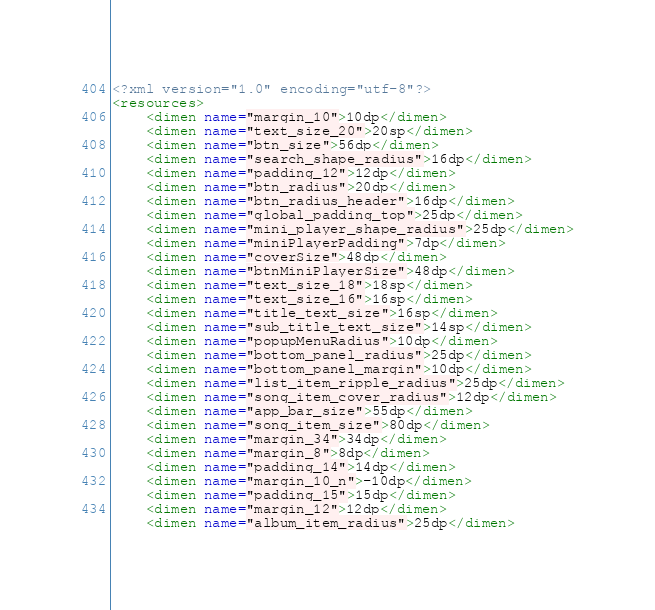<code> <loc_0><loc_0><loc_500><loc_500><_XML_><?xml version="1.0" encoding="utf-8"?>
<resources>
    <dimen name="margin_10">10dp</dimen>
    <dimen name="text_size_20">20sp</dimen>
    <dimen name="btn_size">56dp</dimen>
    <dimen name="search_shape_radius">16dp</dimen>
    <dimen name="padding_12">12dp</dimen>
    <dimen name="btn_radius">20dp</dimen>
    <dimen name="btn_radius_header">16dp</dimen>
    <dimen name="global_padding_top">25dp</dimen>
    <dimen name="mini_player_shape_radius">25dp</dimen>
    <dimen name="miniPlayerPadding">7dp</dimen>
    <dimen name="coverSize">48dp</dimen>
    <dimen name="btnMiniPlayerSize">48dp</dimen>
    <dimen name="text_size_18">18sp</dimen>
    <dimen name="text_size_16">16sp</dimen>
    <dimen name="title_text_size">16sp</dimen>
    <dimen name="sub_title_text_size">14sp</dimen>
    <dimen name="popupMenuRadius">10dp</dimen>
    <dimen name="bottom_panel_radius">25dp</dimen>
    <dimen name="bottom_panel_margin">10dp</dimen>
    <dimen name="list_item_ripple_radius">25dp</dimen>
    <dimen name="song_item_cover_radius">12dp</dimen>
    <dimen name="app_bar_size">55dp</dimen>
    <dimen name="song_item_size">80dp</dimen>
    <dimen name="margin_34">34dp</dimen>
    <dimen name="margin_8">8dp</dimen>
    <dimen name="padding_14">14dp</dimen>
    <dimen name="margin_10_n">-10dp</dimen>
    <dimen name="padding_15">15dp</dimen>
    <dimen name="margin_12">12dp</dimen>
    <dimen name="album_item_radius">25dp</dimen></code> 